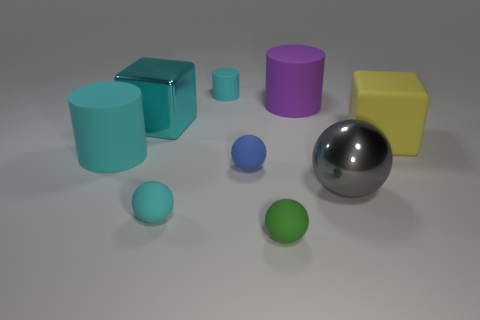Subtract all large cylinders. How many cylinders are left? 1 Subtract all purple cylinders. How many cylinders are left? 2 Subtract all red blocks. How many gray cylinders are left? 0 Subtract 2 blocks. How many blocks are left? 0 Subtract all gray cylinders. Subtract all red blocks. How many cylinders are left? 3 Subtract all cyan metal objects. Subtract all big yellow rubber objects. How many objects are left? 7 Add 7 yellow things. How many yellow things are left? 8 Add 4 large blue blocks. How many large blue blocks exist? 4 Subtract 1 cyan cylinders. How many objects are left? 8 Subtract all balls. How many objects are left? 5 